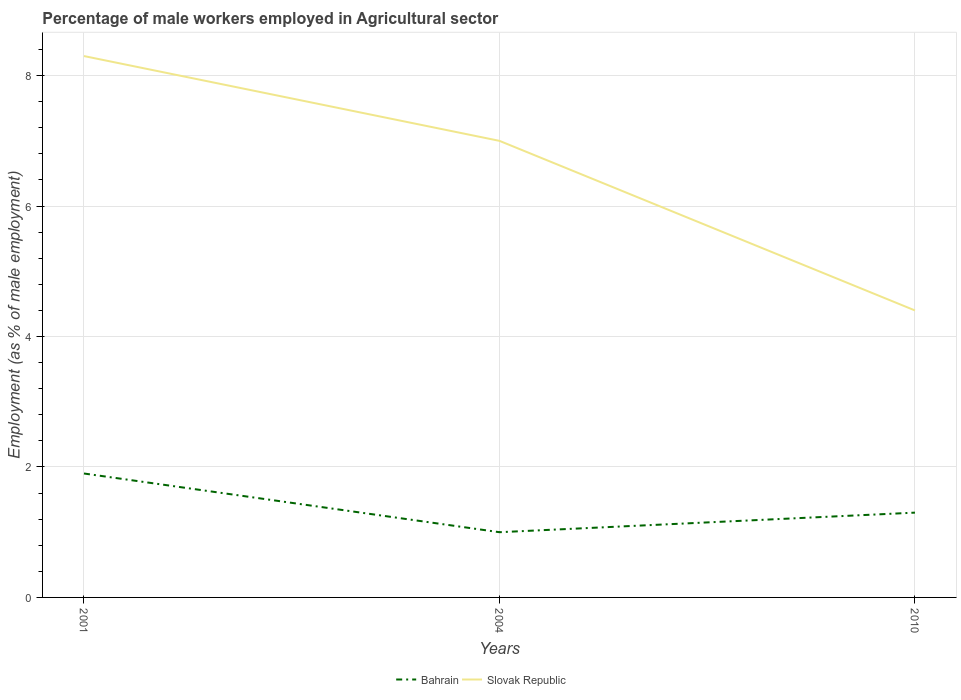Is the number of lines equal to the number of legend labels?
Give a very brief answer. Yes. Across all years, what is the maximum percentage of male workers employed in Agricultural sector in Slovak Republic?
Make the answer very short. 4.4. What is the total percentage of male workers employed in Agricultural sector in Slovak Republic in the graph?
Provide a succinct answer. 1.3. What is the difference between the highest and the second highest percentage of male workers employed in Agricultural sector in Slovak Republic?
Ensure brevity in your answer.  3.9. What is the difference between the highest and the lowest percentage of male workers employed in Agricultural sector in Slovak Republic?
Provide a succinct answer. 2. How many lines are there?
Make the answer very short. 2. What is the difference between two consecutive major ticks on the Y-axis?
Ensure brevity in your answer.  2. Are the values on the major ticks of Y-axis written in scientific E-notation?
Provide a succinct answer. No. Does the graph contain any zero values?
Offer a very short reply. No. Does the graph contain grids?
Offer a terse response. Yes. Where does the legend appear in the graph?
Offer a very short reply. Bottom center. How many legend labels are there?
Keep it short and to the point. 2. What is the title of the graph?
Give a very brief answer. Percentage of male workers employed in Agricultural sector. What is the label or title of the X-axis?
Give a very brief answer. Years. What is the label or title of the Y-axis?
Give a very brief answer. Employment (as % of male employment). What is the Employment (as % of male employment) in Bahrain in 2001?
Offer a very short reply. 1.9. What is the Employment (as % of male employment) of Slovak Republic in 2001?
Offer a terse response. 8.3. What is the Employment (as % of male employment) of Slovak Republic in 2004?
Your response must be concise. 7. What is the Employment (as % of male employment) in Bahrain in 2010?
Your answer should be compact. 1.3. What is the Employment (as % of male employment) in Slovak Republic in 2010?
Offer a very short reply. 4.4. Across all years, what is the maximum Employment (as % of male employment) of Bahrain?
Provide a short and direct response. 1.9. Across all years, what is the maximum Employment (as % of male employment) of Slovak Republic?
Offer a terse response. 8.3. Across all years, what is the minimum Employment (as % of male employment) of Bahrain?
Keep it short and to the point. 1. Across all years, what is the minimum Employment (as % of male employment) in Slovak Republic?
Offer a terse response. 4.4. What is the difference between the Employment (as % of male employment) of Slovak Republic in 2001 and that in 2010?
Your answer should be compact. 3.9. What is the difference between the Employment (as % of male employment) of Bahrain in 2004 and that in 2010?
Give a very brief answer. -0.3. What is the difference between the Employment (as % of male employment) of Slovak Republic in 2004 and that in 2010?
Provide a succinct answer. 2.6. What is the difference between the Employment (as % of male employment) of Bahrain in 2001 and the Employment (as % of male employment) of Slovak Republic in 2004?
Keep it short and to the point. -5.1. What is the difference between the Employment (as % of male employment) in Bahrain in 2001 and the Employment (as % of male employment) in Slovak Republic in 2010?
Your response must be concise. -2.5. What is the difference between the Employment (as % of male employment) of Bahrain in 2004 and the Employment (as % of male employment) of Slovak Republic in 2010?
Give a very brief answer. -3.4. What is the average Employment (as % of male employment) in Slovak Republic per year?
Provide a short and direct response. 6.57. In the year 2001, what is the difference between the Employment (as % of male employment) in Bahrain and Employment (as % of male employment) in Slovak Republic?
Offer a terse response. -6.4. What is the ratio of the Employment (as % of male employment) of Slovak Republic in 2001 to that in 2004?
Keep it short and to the point. 1.19. What is the ratio of the Employment (as % of male employment) in Bahrain in 2001 to that in 2010?
Keep it short and to the point. 1.46. What is the ratio of the Employment (as % of male employment) of Slovak Republic in 2001 to that in 2010?
Give a very brief answer. 1.89. What is the ratio of the Employment (as % of male employment) in Bahrain in 2004 to that in 2010?
Provide a succinct answer. 0.77. What is the ratio of the Employment (as % of male employment) of Slovak Republic in 2004 to that in 2010?
Your answer should be compact. 1.59. What is the difference between the highest and the second highest Employment (as % of male employment) in Bahrain?
Your answer should be compact. 0.6. What is the difference between the highest and the second highest Employment (as % of male employment) in Slovak Republic?
Provide a succinct answer. 1.3. What is the difference between the highest and the lowest Employment (as % of male employment) of Bahrain?
Your response must be concise. 0.9. What is the difference between the highest and the lowest Employment (as % of male employment) of Slovak Republic?
Ensure brevity in your answer.  3.9. 